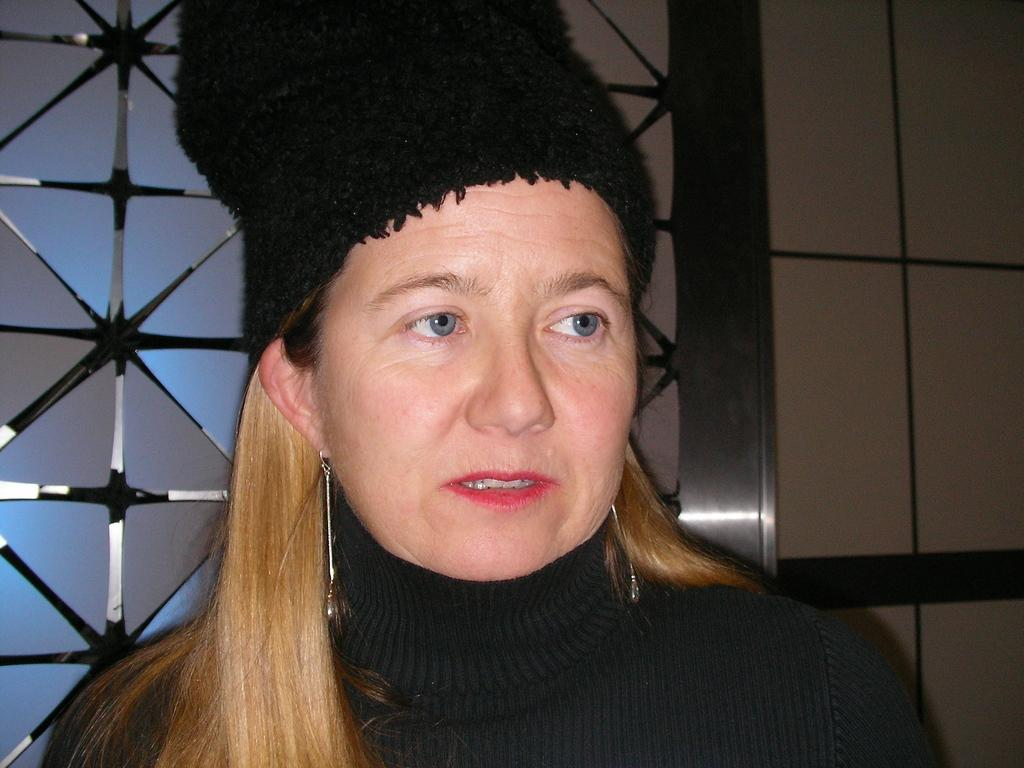Who is present in the image? There is a woman in the image. What is the woman wearing on her head? The woman is wearing a black cap. What color is the dress the woman is wearing? The woman is wearing a black dress. What type of insect can be seen crawling on the woman's dress in the image? There is no insect present on the woman's dress in the image. 